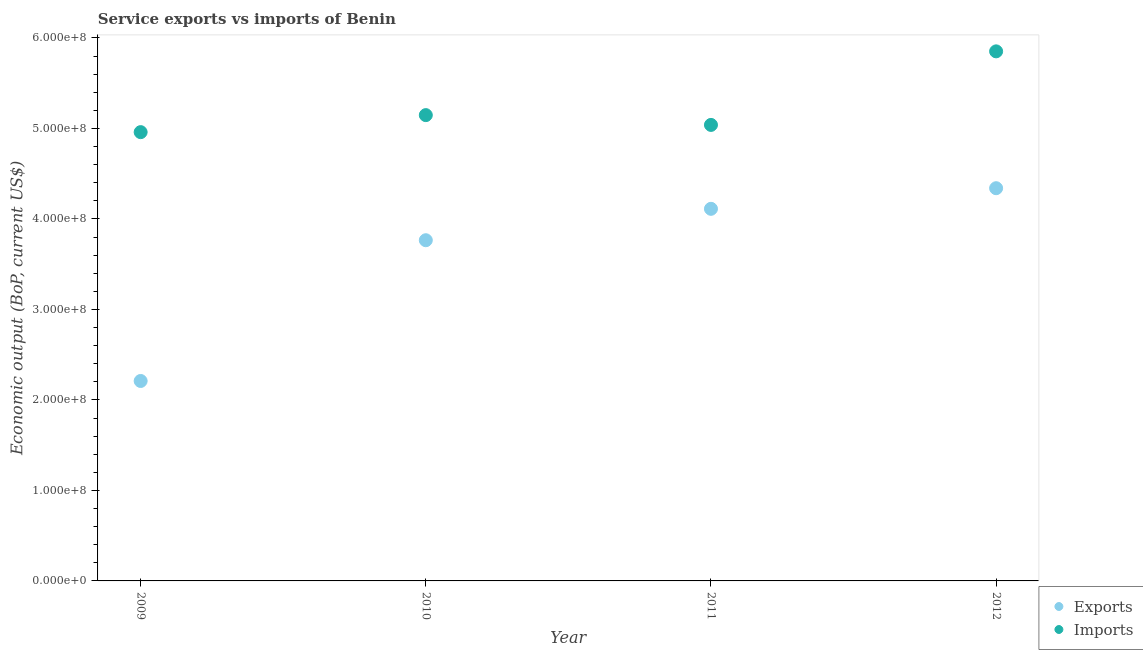Is the number of dotlines equal to the number of legend labels?
Keep it short and to the point. Yes. What is the amount of service exports in 2012?
Offer a terse response. 4.34e+08. Across all years, what is the maximum amount of service exports?
Keep it short and to the point. 4.34e+08. Across all years, what is the minimum amount of service imports?
Provide a short and direct response. 4.96e+08. In which year was the amount of service exports minimum?
Give a very brief answer. 2009. What is the total amount of service exports in the graph?
Your response must be concise. 1.44e+09. What is the difference between the amount of service exports in 2010 and that in 2012?
Offer a terse response. -5.75e+07. What is the difference between the amount of service imports in 2011 and the amount of service exports in 2009?
Provide a succinct answer. 2.83e+08. What is the average amount of service exports per year?
Provide a succinct answer. 3.61e+08. In the year 2012, what is the difference between the amount of service imports and amount of service exports?
Ensure brevity in your answer.  1.51e+08. In how many years, is the amount of service exports greater than 460000000 US$?
Ensure brevity in your answer.  0. What is the ratio of the amount of service imports in 2011 to that in 2012?
Ensure brevity in your answer.  0.86. Is the amount of service imports in 2009 less than that in 2012?
Give a very brief answer. Yes. Is the difference between the amount of service imports in 2011 and 2012 greater than the difference between the amount of service exports in 2011 and 2012?
Make the answer very short. No. What is the difference between the highest and the second highest amount of service imports?
Give a very brief answer. 7.05e+07. What is the difference between the highest and the lowest amount of service imports?
Your answer should be very brief. 8.93e+07. How many years are there in the graph?
Your response must be concise. 4. Does the graph contain any zero values?
Provide a short and direct response. No. Does the graph contain grids?
Your answer should be very brief. No. Where does the legend appear in the graph?
Ensure brevity in your answer.  Bottom right. How are the legend labels stacked?
Your answer should be very brief. Vertical. What is the title of the graph?
Provide a short and direct response. Service exports vs imports of Benin. Does "Official creditors" appear as one of the legend labels in the graph?
Your answer should be compact. No. What is the label or title of the X-axis?
Keep it short and to the point. Year. What is the label or title of the Y-axis?
Keep it short and to the point. Economic output (BoP, current US$). What is the Economic output (BoP, current US$) of Exports in 2009?
Your answer should be very brief. 2.21e+08. What is the Economic output (BoP, current US$) of Imports in 2009?
Keep it short and to the point. 4.96e+08. What is the Economic output (BoP, current US$) of Exports in 2010?
Offer a terse response. 3.76e+08. What is the Economic output (BoP, current US$) of Imports in 2010?
Ensure brevity in your answer.  5.15e+08. What is the Economic output (BoP, current US$) of Exports in 2011?
Offer a very short reply. 4.11e+08. What is the Economic output (BoP, current US$) in Imports in 2011?
Offer a terse response. 5.04e+08. What is the Economic output (BoP, current US$) of Exports in 2012?
Provide a short and direct response. 4.34e+08. What is the Economic output (BoP, current US$) of Imports in 2012?
Offer a terse response. 5.85e+08. Across all years, what is the maximum Economic output (BoP, current US$) of Exports?
Offer a very short reply. 4.34e+08. Across all years, what is the maximum Economic output (BoP, current US$) of Imports?
Your answer should be compact. 5.85e+08. Across all years, what is the minimum Economic output (BoP, current US$) of Exports?
Your response must be concise. 2.21e+08. Across all years, what is the minimum Economic output (BoP, current US$) in Imports?
Ensure brevity in your answer.  4.96e+08. What is the total Economic output (BoP, current US$) of Exports in the graph?
Offer a terse response. 1.44e+09. What is the total Economic output (BoP, current US$) in Imports in the graph?
Your answer should be compact. 2.10e+09. What is the difference between the Economic output (BoP, current US$) of Exports in 2009 and that in 2010?
Your answer should be compact. -1.56e+08. What is the difference between the Economic output (BoP, current US$) in Imports in 2009 and that in 2010?
Your response must be concise. -1.88e+07. What is the difference between the Economic output (BoP, current US$) of Exports in 2009 and that in 2011?
Your response must be concise. -1.90e+08. What is the difference between the Economic output (BoP, current US$) of Imports in 2009 and that in 2011?
Your answer should be compact. -7.99e+06. What is the difference between the Economic output (BoP, current US$) of Exports in 2009 and that in 2012?
Offer a terse response. -2.13e+08. What is the difference between the Economic output (BoP, current US$) of Imports in 2009 and that in 2012?
Keep it short and to the point. -8.93e+07. What is the difference between the Economic output (BoP, current US$) of Exports in 2010 and that in 2011?
Provide a short and direct response. -3.47e+07. What is the difference between the Economic output (BoP, current US$) in Imports in 2010 and that in 2011?
Your answer should be compact. 1.08e+07. What is the difference between the Economic output (BoP, current US$) of Exports in 2010 and that in 2012?
Give a very brief answer. -5.75e+07. What is the difference between the Economic output (BoP, current US$) in Imports in 2010 and that in 2012?
Your answer should be very brief. -7.05e+07. What is the difference between the Economic output (BoP, current US$) of Exports in 2011 and that in 2012?
Provide a short and direct response. -2.28e+07. What is the difference between the Economic output (BoP, current US$) in Imports in 2011 and that in 2012?
Make the answer very short. -8.13e+07. What is the difference between the Economic output (BoP, current US$) of Exports in 2009 and the Economic output (BoP, current US$) of Imports in 2010?
Make the answer very short. -2.94e+08. What is the difference between the Economic output (BoP, current US$) in Exports in 2009 and the Economic output (BoP, current US$) in Imports in 2011?
Ensure brevity in your answer.  -2.83e+08. What is the difference between the Economic output (BoP, current US$) of Exports in 2009 and the Economic output (BoP, current US$) of Imports in 2012?
Your answer should be compact. -3.64e+08. What is the difference between the Economic output (BoP, current US$) in Exports in 2010 and the Economic output (BoP, current US$) in Imports in 2011?
Provide a succinct answer. -1.27e+08. What is the difference between the Economic output (BoP, current US$) of Exports in 2010 and the Economic output (BoP, current US$) of Imports in 2012?
Your answer should be very brief. -2.09e+08. What is the difference between the Economic output (BoP, current US$) in Exports in 2011 and the Economic output (BoP, current US$) in Imports in 2012?
Offer a terse response. -1.74e+08. What is the average Economic output (BoP, current US$) of Exports per year?
Your answer should be very brief. 3.61e+08. What is the average Economic output (BoP, current US$) in Imports per year?
Your response must be concise. 5.25e+08. In the year 2009, what is the difference between the Economic output (BoP, current US$) of Exports and Economic output (BoP, current US$) of Imports?
Your response must be concise. -2.75e+08. In the year 2010, what is the difference between the Economic output (BoP, current US$) in Exports and Economic output (BoP, current US$) in Imports?
Provide a short and direct response. -1.38e+08. In the year 2011, what is the difference between the Economic output (BoP, current US$) of Exports and Economic output (BoP, current US$) of Imports?
Keep it short and to the point. -9.27e+07. In the year 2012, what is the difference between the Economic output (BoP, current US$) in Exports and Economic output (BoP, current US$) in Imports?
Your answer should be very brief. -1.51e+08. What is the ratio of the Economic output (BoP, current US$) in Exports in 2009 to that in 2010?
Provide a succinct answer. 0.59. What is the ratio of the Economic output (BoP, current US$) in Imports in 2009 to that in 2010?
Your response must be concise. 0.96. What is the ratio of the Economic output (BoP, current US$) of Exports in 2009 to that in 2011?
Provide a short and direct response. 0.54. What is the ratio of the Economic output (BoP, current US$) in Imports in 2009 to that in 2011?
Offer a very short reply. 0.98. What is the ratio of the Economic output (BoP, current US$) in Exports in 2009 to that in 2012?
Give a very brief answer. 0.51. What is the ratio of the Economic output (BoP, current US$) of Imports in 2009 to that in 2012?
Your answer should be compact. 0.85. What is the ratio of the Economic output (BoP, current US$) of Exports in 2010 to that in 2011?
Offer a very short reply. 0.92. What is the ratio of the Economic output (BoP, current US$) in Imports in 2010 to that in 2011?
Your answer should be very brief. 1.02. What is the ratio of the Economic output (BoP, current US$) of Exports in 2010 to that in 2012?
Your response must be concise. 0.87. What is the ratio of the Economic output (BoP, current US$) of Imports in 2010 to that in 2012?
Keep it short and to the point. 0.88. What is the ratio of the Economic output (BoP, current US$) in Exports in 2011 to that in 2012?
Keep it short and to the point. 0.95. What is the ratio of the Economic output (BoP, current US$) of Imports in 2011 to that in 2012?
Your response must be concise. 0.86. What is the difference between the highest and the second highest Economic output (BoP, current US$) in Exports?
Give a very brief answer. 2.28e+07. What is the difference between the highest and the second highest Economic output (BoP, current US$) in Imports?
Provide a succinct answer. 7.05e+07. What is the difference between the highest and the lowest Economic output (BoP, current US$) in Exports?
Provide a succinct answer. 2.13e+08. What is the difference between the highest and the lowest Economic output (BoP, current US$) in Imports?
Your response must be concise. 8.93e+07. 